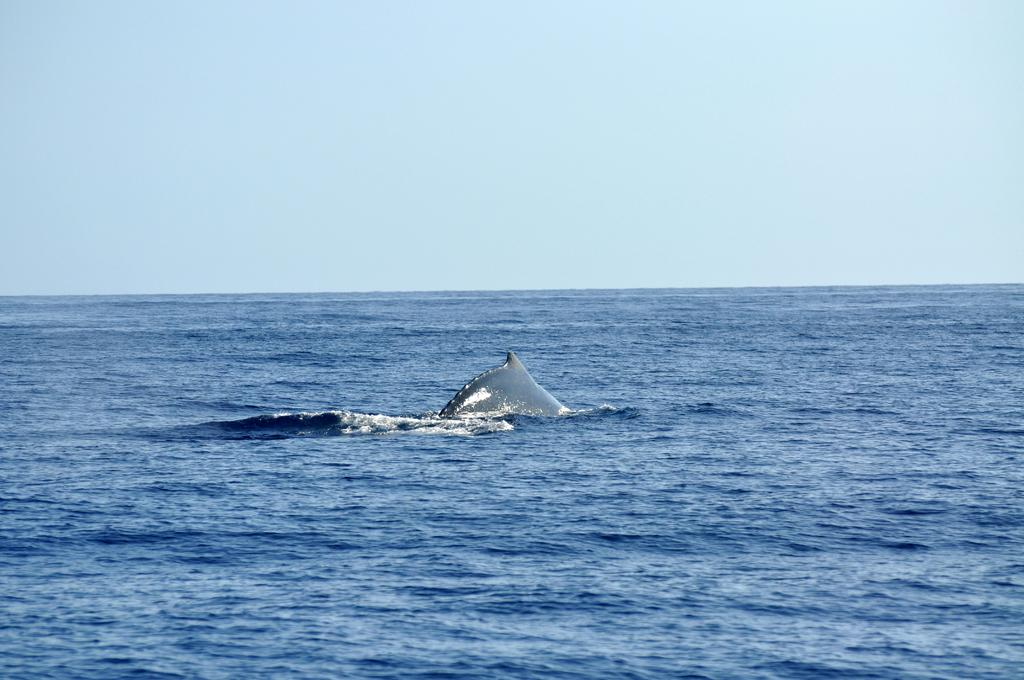What is the main subject of the image? There is a fish in the image. Where is the fish located? The fish is in the water. What part of the natural environment is visible in the image? The sky is visible in the image. Can you make an educated guess about the location of the image? The image may have been taken in the ocean, given the presence of water and the fish. What time of day might the image have been taken? The image was likely taken during the day, as the sky is visible. What type of temper does the fish have in the image? There is no indication of the fish's temper in the image, as it is a photograph and does not capture emotions or behaviors. 